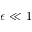<formula> <loc_0><loc_0><loc_500><loc_500>\epsilon \ll 1</formula> 